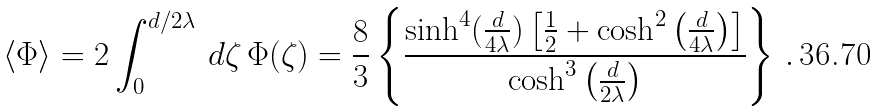Convert formula to latex. <formula><loc_0><loc_0><loc_500><loc_500>\left < \Phi \right > = 2 \int _ { 0 } ^ { d / 2 \lambda } \, d \zeta \, \Phi ( \zeta ) = \frac { 8 } { 3 } \left \{ \frac { \sinh ^ { 4 } ( \frac { d } { 4 \lambda } ) \left [ \frac { 1 } { 2 } + \cosh ^ { 2 } \left ( \frac { d } { 4 \lambda } \right ) \right ] } { \cosh ^ { 3 } \left ( \frac { d } { 2 \lambda } \right ) } \right \} \, .</formula> 